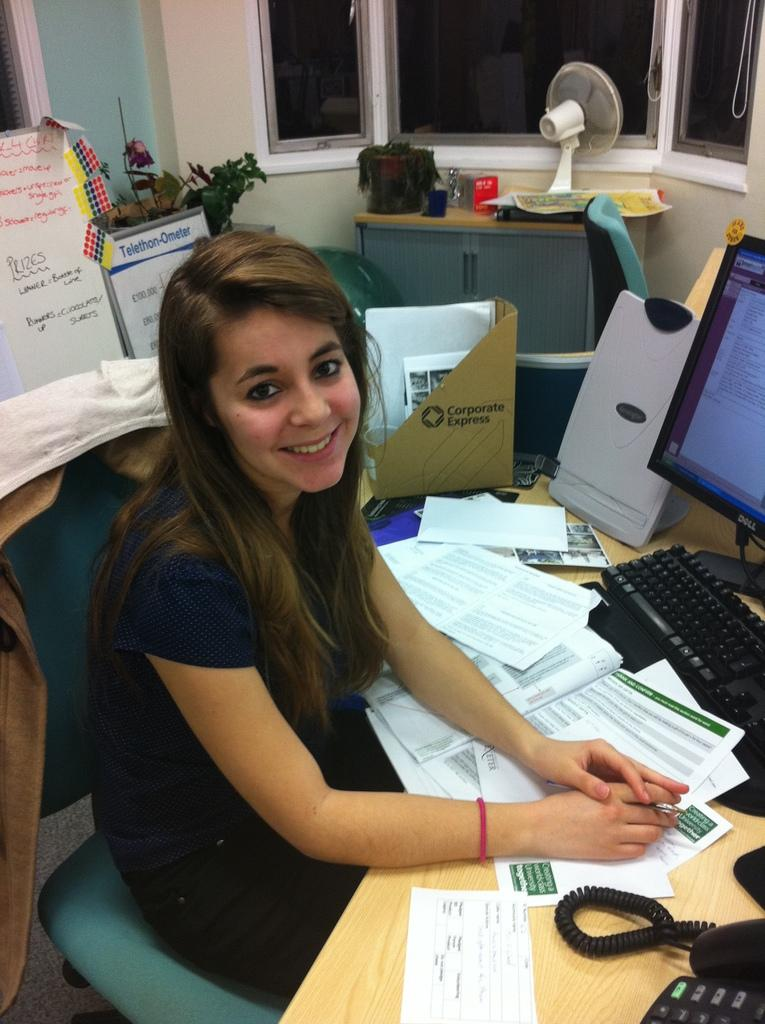<image>
Provide a brief description of the given image. A lady sitting at her desk with a Corporate Express folder behind her. 